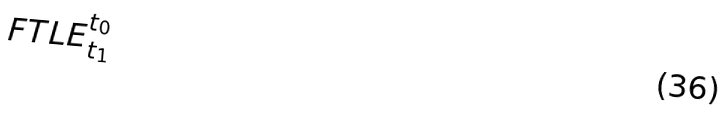<formula> <loc_0><loc_0><loc_500><loc_500>F T L E _ { t _ { 1 } } ^ { t _ { 0 } }</formula> 